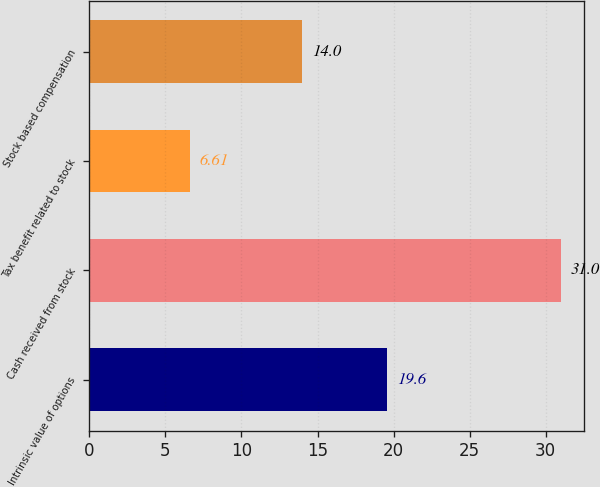Convert chart to OTSL. <chart><loc_0><loc_0><loc_500><loc_500><bar_chart><fcel>Intrinsic value of options<fcel>Cash received from stock<fcel>Tax benefit related to stock<fcel>Stock based compensation<nl><fcel>19.6<fcel>31<fcel>6.61<fcel>14<nl></chart> 